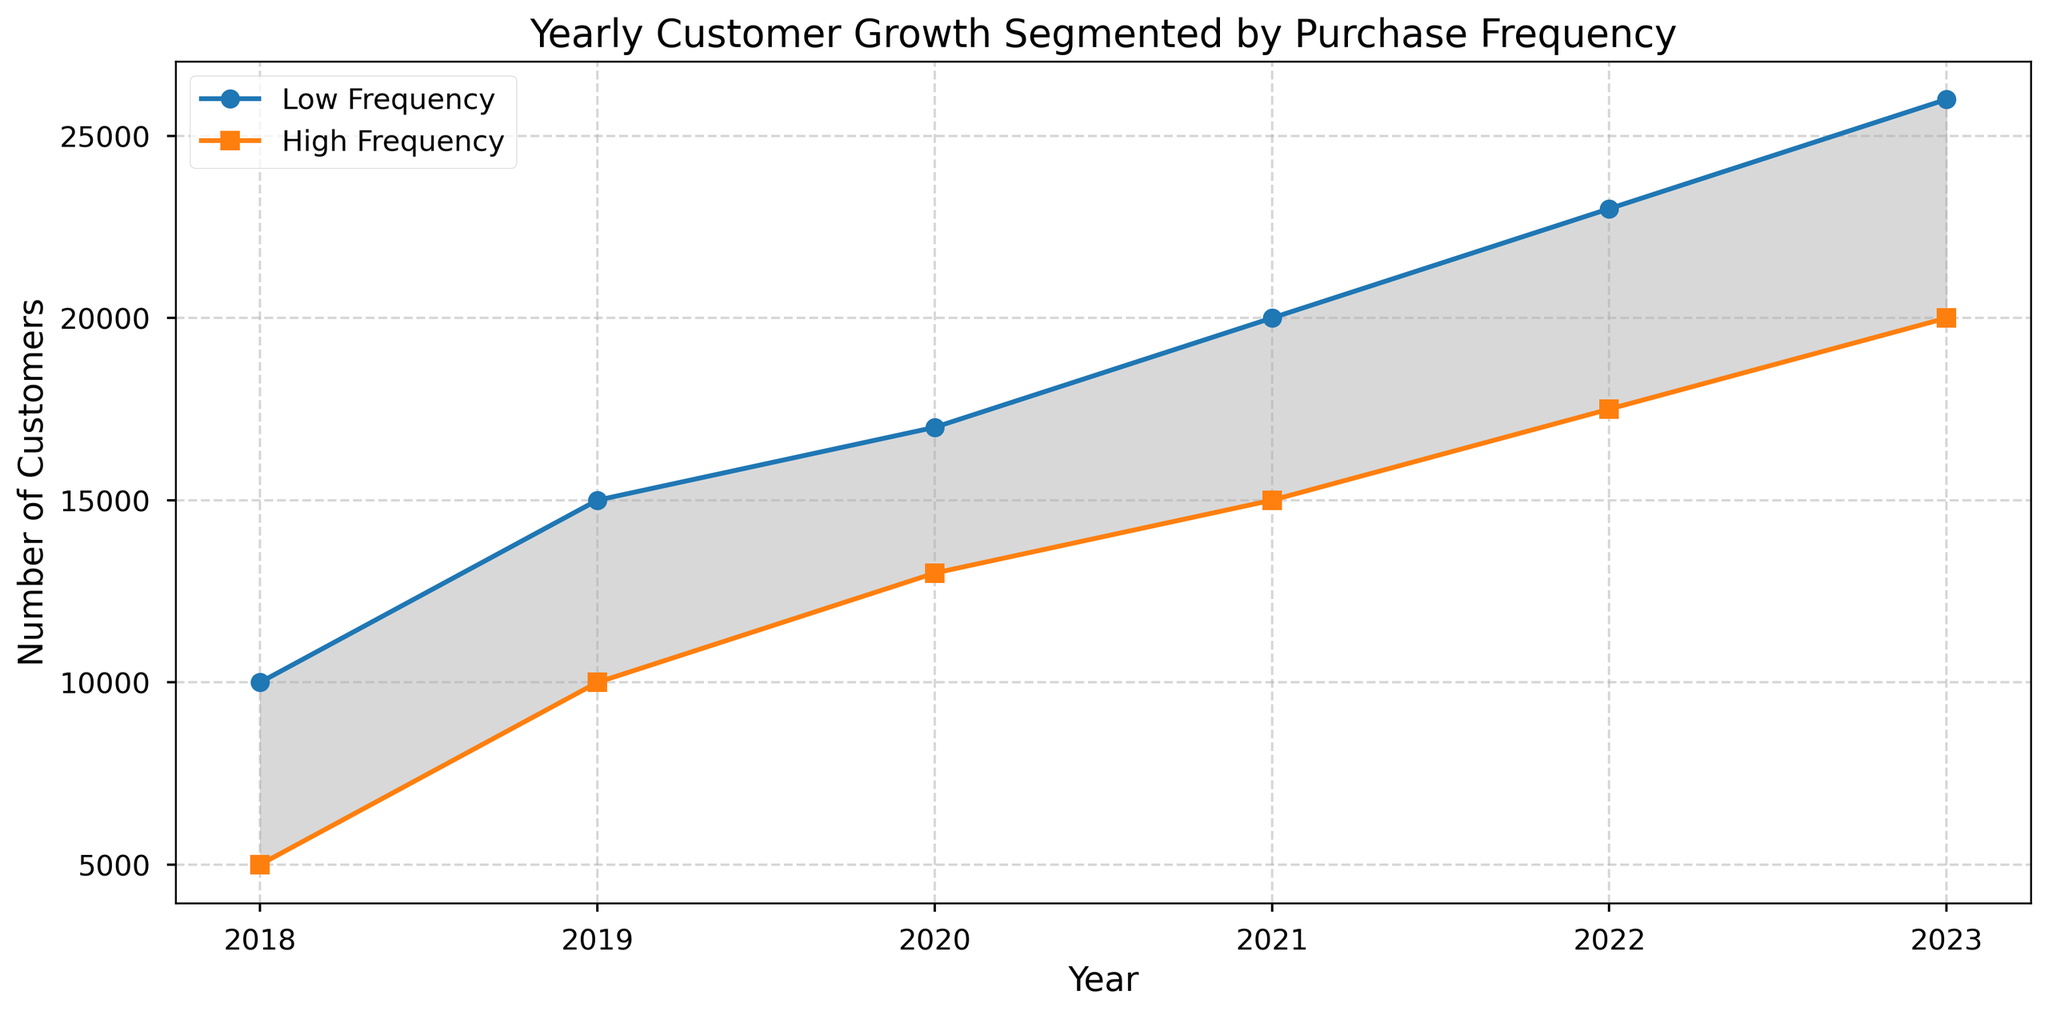What is the trend of customer growth for low-frequency purchasers from 2018 to 2023? Look at the line representing low-frequency customers on the chart. The number of low-frequency purchasers increases steadily each year from 20,000 in 2018 to 36,000 in 2023.
Answer: Increasing How much greater is the customer growth in 2023 compared to 2018 for high-frequency purchasers? The number of high-frequency purchasers in 2023 is 30,000, and in 2018 it was 15,000. Subtract 15,000 from 30,000.
Answer: 15,000 Which year saw the smallest gap between low-frequency and high-frequency customers? Look at the shaded area between the lines. The smallest gap appears to be in 2018 and 2019. Verify by calculating the differences: 20,000 - 15,000 = 5,000 in 2018, and 25,000 - 20,000 = 5,000 in 2019. The gap is the same in both years.
Answer: 2018 or 2019 What is the average annual increase in the number of high-frequency customers from 2018 to 2023? Calculate the total increase: 2023 (30,000) - 2018 (15,000) = 15,000. Divide by the number of years: 15,000 / 5.
Answer: 3,000 per year In which year did low-frequency purchasers reach 30,000 customers? Locate the low-frequency line and see when it crosses the 30,000 mark. This occurs in 2021.
Answer: 2021 Compare the customer growth between 2020 and 2021 for low-frequency and high-frequency purchasers. Identify the values for 2020 and 2021. For low-frequency: 30,000 (2021) - 27,000 (2020) = 3,000. For high-frequency: 25,000 (2021) - 23,000 (2020) = 2,000. Low-frequency growth is 3,000; high-frequency growth is 2,000.
Answer: Low-frequency: 3,000; High-frequency: 2,000 What is the range of high-frequency customer growth from 2018 to 2023? Range is the difference between the maximum and minimum values. High-frequency customers in 2023 = 30,000; in 2018 = 15,000. Range = 30,000 - 15,000.
Answer: 15,000 What color represents high-frequency purchasers in the chart? Examine the legend or the color of the line representing high-frequency purchasers. The high-frequency line is shown in orange.
Answer: Orange Is the number of low-frequency customers greater than high-frequency customers every year? Compare the values of low-frequency and high-frequency customers for each year (2018–2023). The low-frequency customers are higher every year.
Answer: Yes 